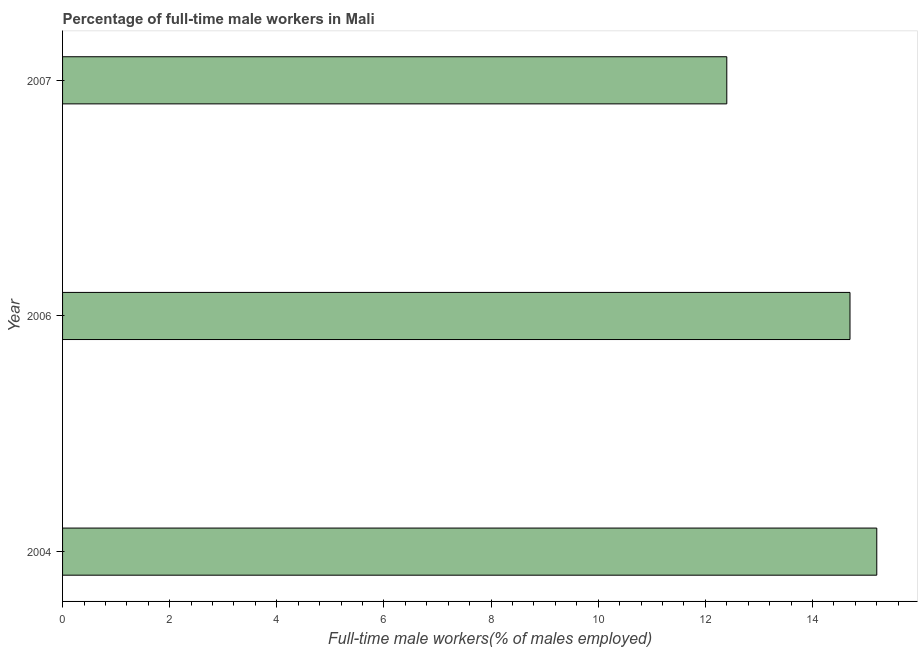What is the title of the graph?
Offer a very short reply. Percentage of full-time male workers in Mali. What is the label or title of the X-axis?
Provide a succinct answer. Full-time male workers(% of males employed). What is the percentage of full-time male workers in 2007?
Keep it short and to the point. 12.4. Across all years, what is the maximum percentage of full-time male workers?
Ensure brevity in your answer.  15.2. Across all years, what is the minimum percentage of full-time male workers?
Offer a very short reply. 12.4. In which year was the percentage of full-time male workers maximum?
Offer a very short reply. 2004. What is the sum of the percentage of full-time male workers?
Ensure brevity in your answer.  42.3. What is the median percentage of full-time male workers?
Your answer should be very brief. 14.7. In how many years, is the percentage of full-time male workers greater than 8.4 %?
Provide a short and direct response. 3. Do a majority of the years between 2006 and 2007 (inclusive) have percentage of full-time male workers greater than 11.2 %?
Your response must be concise. Yes. What is the ratio of the percentage of full-time male workers in 2004 to that in 2006?
Your answer should be compact. 1.03. How many bars are there?
Your answer should be compact. 3. Are all the bars in the graph horizontal?
Keep it short and to the point. Yes. Are the values on the major ticks of X-axis written in scientific E-notation?
Provide a succinct answer. No. What is the Full-time male workers(% of males employed) of 2004?
Provide a short and direct response. 15.2. What is the Full-time male workers(% of males employed) of 2006?
Your answer should be compact. 14.7. What is the Full-time male workers(% of males employed) in 2007?
Ensure brevity in your answer.  12.4. What is the difference between the Full-time male workers(% of males employed) in 2004 and 2006?
Provide a succinct answer. 0.5. What is the ratio of the Full-time male workers(% of males employed) in 2004 to that in 2006?
Your response must be concise. 1.03. What is the ratio of the Full-time male workers(% of males employed) in 2004 to that in 2007?
Your answer should be very brief. 1.23. What is the ratio of the Full-time male workers(% of males employed) in 2006 to that in 2007?
Provide a succinct answer. 1.19. 